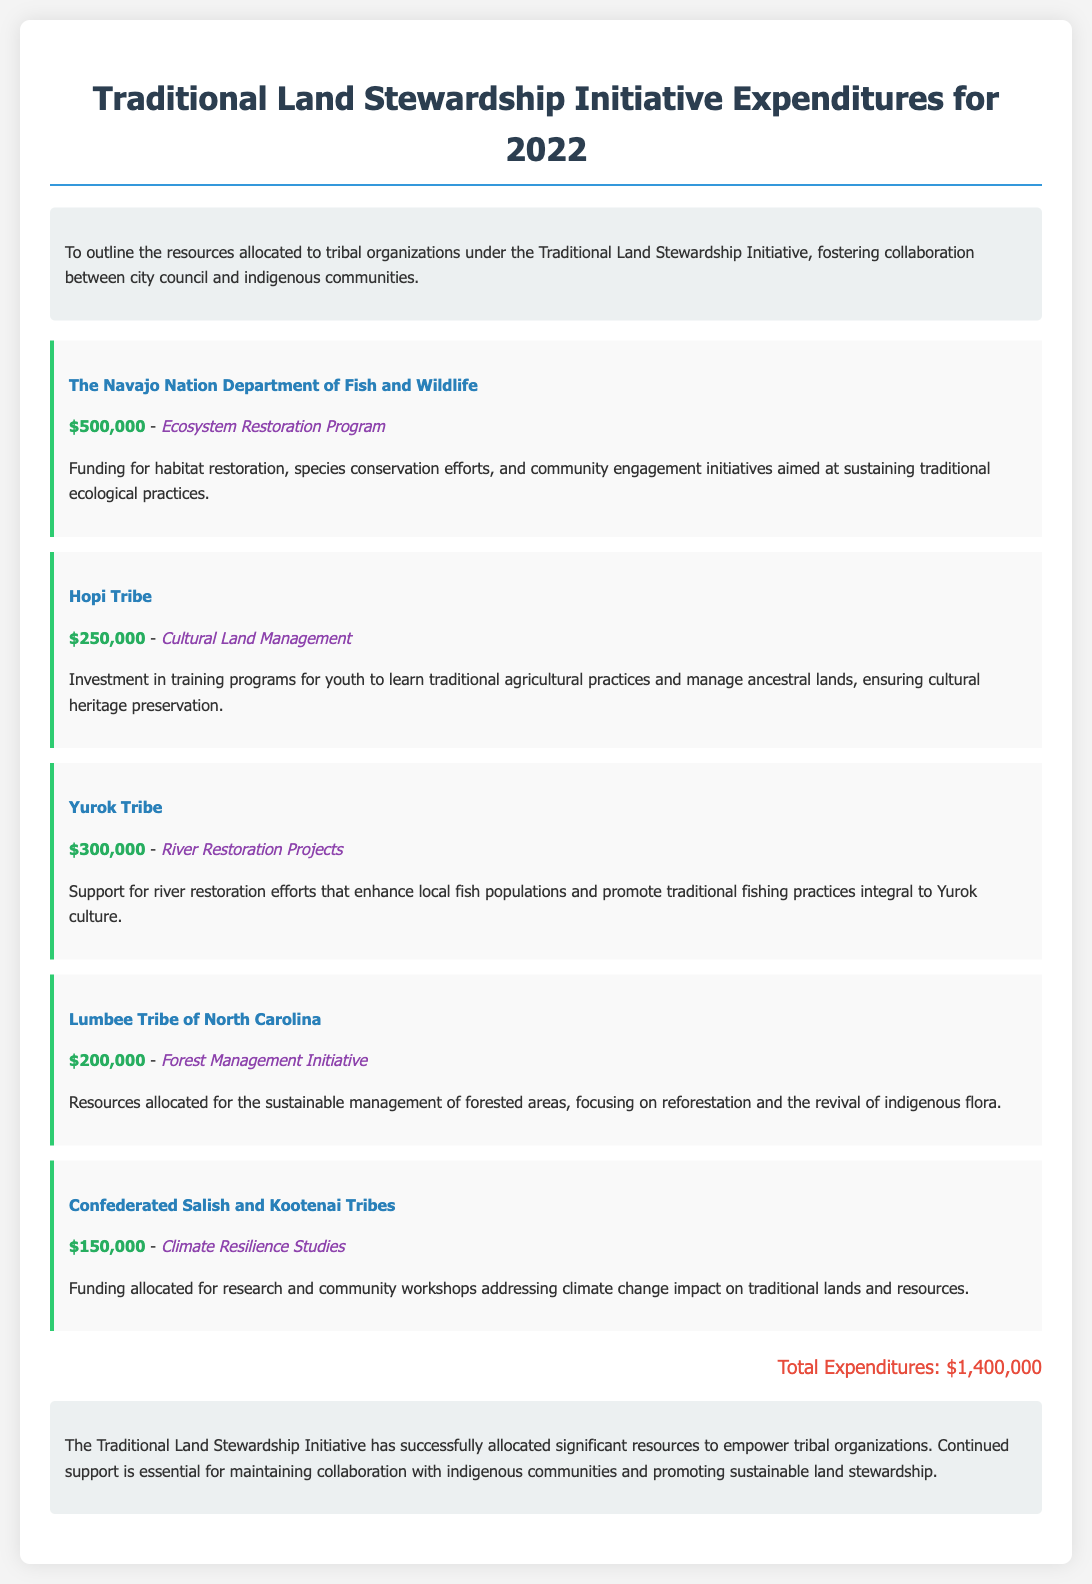What is the total expenditure? The total expenditure is the sum of all the allocated amounts to tribal organizations, which is $1,400,000.
Answer: $1,400,000 How much funding was allocated to the Navajo Nation Department of Fish and Wildlife? The document specifies that the Navajo Nation Department of Fish and Wildlife received a funding allocation of $500,000.
Answer: $500,000 What project is associated with the Hopi Tribe? The Hopi Tribe is associated with the project "Cultural Land Management."
Answer: Cultural Land Management Which tribe received funding for river restoration projects? The document indicates that the Yurok Tribe received funding specifically for river restoration projects.
Answer: Yurok Tribe How much was allocated to the Lumbee Tribe of North Carolina? The funding allocated to the Lumbee Tribe of North Carolina is stated as $200,000.
Answer: $200,000 What is the main focus of the funding for the Confederated Salish and Kootenai Tribes? The main focus of the funding for the Confederated Salish and Kootenai Tribes is for "Climate Resilience Studies."
Answer: Climate Resilience Studies How many tribal organizations received funding? The document lists five tribal organizations that received funding allocations.
Answer: Five What is the aim of the Yurok Tribe's restoration projects? The aim of the Yurok Tribe's restoration projects is to enhance local fish populations and promote traditional fishing practices integral to Yurok culture.
Answer: Enhance local fish populations What initiatives does the Traditional Land Stewardship Initiative primarily support? The initiative primarily supports traditional ecological practices and cultural heritage preservation among tribal organizations.
Answer: Traditional ecological practices and cultural heritage preservation 